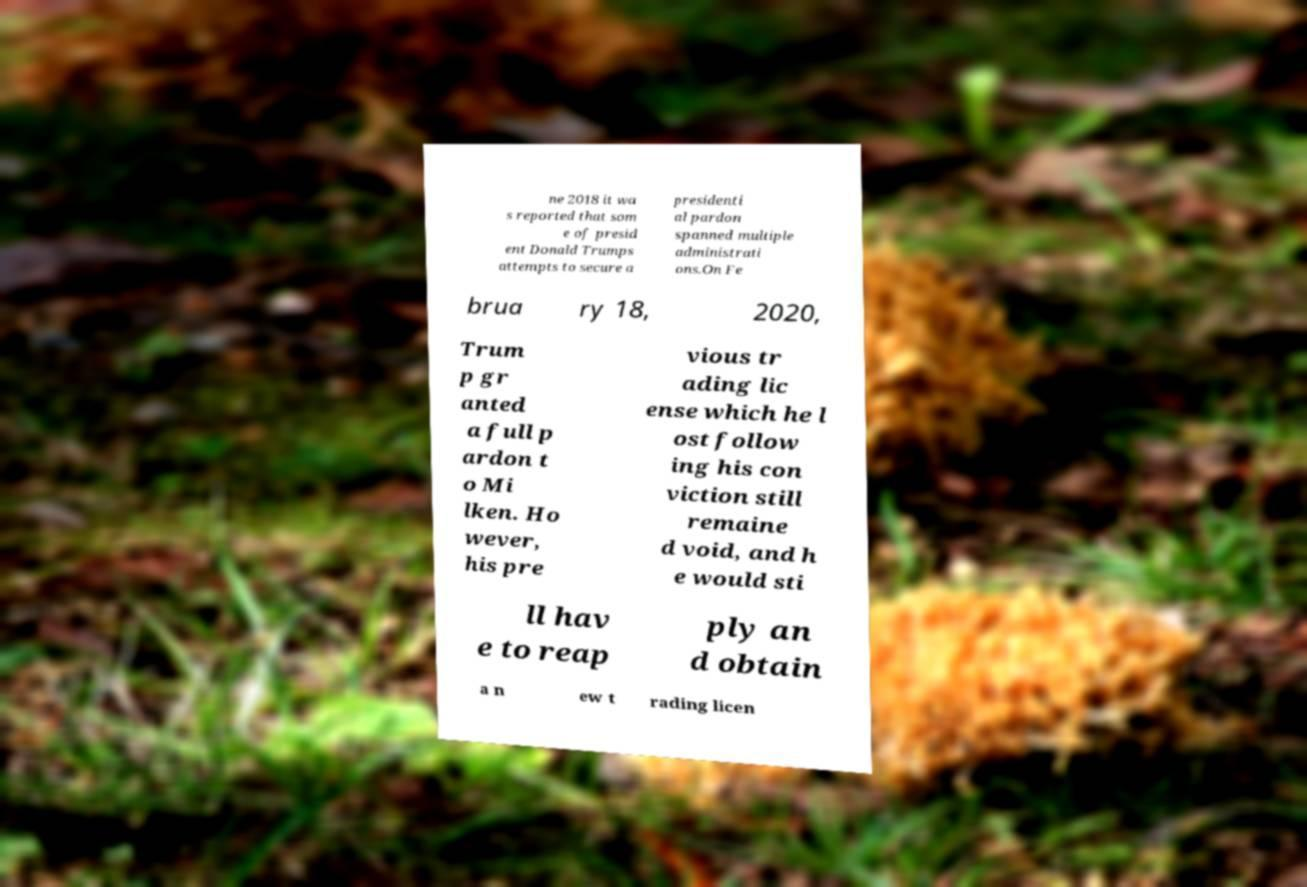For documentation purposes, I need the text within this image transcribed. Could you provide that? ne 2018 it wa s reported that som e of presid ent Donald Trumps attempts to secure a presidenti al pardon spanned multiple administrati ons.On Fe brua ry 18, 2020, Trum p gr anted a full p ardon t o Mi lken. Ho wever, his pre vious tr ading lic ense which he l ost follow ing his con viction still remaine d void, and h e would sti ll hav e to reap ply an d obtain a n ew t rading licen 